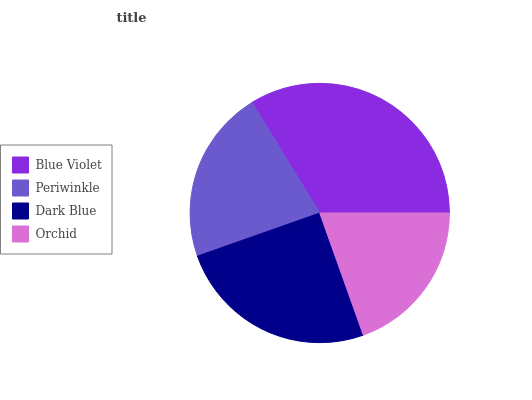Is Orchid the minimum?
Answer yes or no. Yes. Is Blue Violet the maximum?
Answer yes or no. Yes. Is Periwinkle the minimum?
Answer yes or no. No. Is Periwinkle the maximum?
Answer yes or no. No. Is Blue Violet greater than Periwinkle?
Answer yes or no. Yes. Is Periwinkle less than Blue Violet?
Answer yes or no. Yes. Is Periwinkle greater than Blue Violet?
Answer yes or no. No. Is Blue Violet less than Periwinkle?
Answer yes or no. No. Is Dark Blue the high median?
Answer yes or no. Yes. Is Periwinkle the low median?
Answer yes or no. Yes. Is Blue Violet the high median?
Answer yes or no. No. Is Blue Violet the low median?
Answer yes or no. No. 